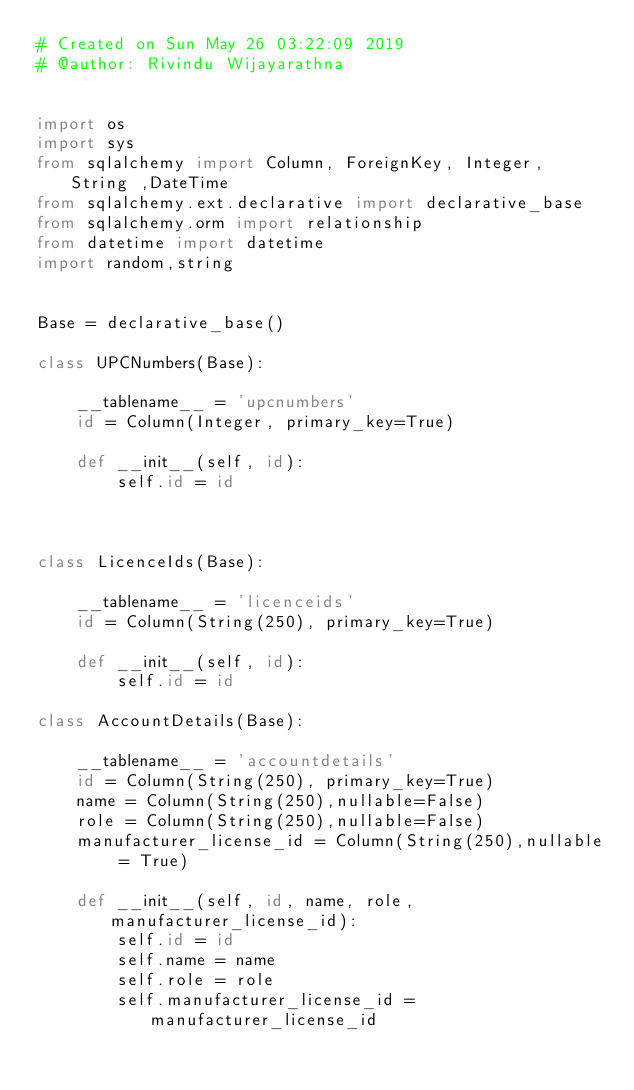<code> <loc_0><loc_0><loc_500><loc_500><_Python_># Created on Sun May 26 03:22:09 2019
# @author: Rivindu Wijayarathna


import os
import sys
from sqlalchemy import Column, ForeignKey, Integer, String ,DateTime
from sqlalchemy.ext.declarative import declarative_base
from sqlalchemy.orm import relationship
from datetime import datetime
import random,string

 
Base = declarative_base()

class UPCNumbers(Base):
    
    __tablename__ = 'upcnumbers'
    id = Column(Integer, primary_key=True)
    
    def __init__(self, id):
        self.id = id

        

class LicenceIds(Base):
    
    __tablename__ = 'licenceids'
    id = Column(String(250), primary_key=True)
    
    def __init__(self, id):
        self.id = id

class AccountDetails(Base):
    
    __tablename__ = 'accountdetails'
    id = Column(String(250), primary_key=True)
    name = Column(String(250),nullable=False)
    role = Column(String(250),nullable=False)
    manufacturer_license_id = Column(String(250),nullable = True)

    def __init__(self, id, name, role, manufacturer_license_id):
        self.id = id
        self.name = name
        self.role = role
        self.manufacturer_license_id = manufacturer_license_id</code> 